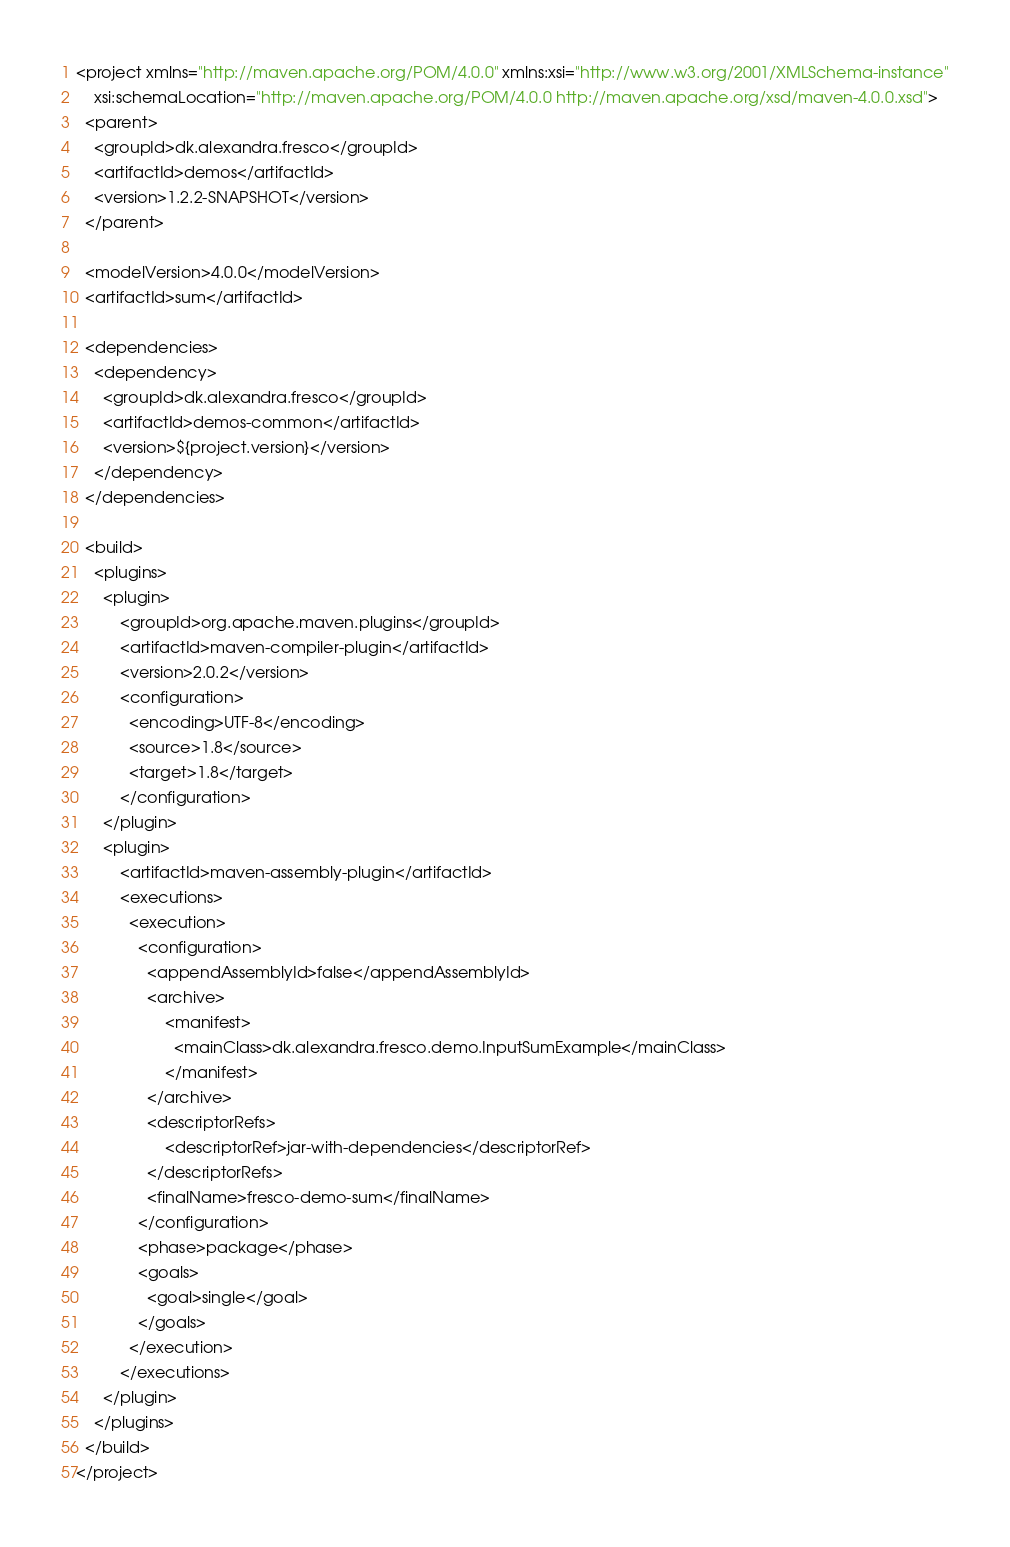<code> <loc_0><loc_0><loc_500><loc_500><_XML_><project xmlns="http://maven.apache.org/POM/4.0.0" xmlns:xsi="http://www.w3.org/2001/XMLSchema-instance"
    xsi:schemaLocation="http://maven.apache.org/POM/4.0.0 http://maven.apache.org/xsd/maven-4.0.0.xsd">
  <parent>
    <groupId>dk.alexandra.fresco</groupId>
    <artifactId>demos</artifactId>
    <version>1.2.2-SNAPSHOT</version>
  </parent>

  <modelVersion>4.0.0</modelVersion>
  <artifactId>sum</artifactId>

  <dependencies>
    <dependency>
      <groupId>dk.alexandra.fresco</groupId>
      <artifactId>demos-common</artifactId>
      <version>${project.version}</version>
    </dependency>
  </dependencies>
  
  <build>
    <plugins>
      <plugin>
	      <groupId>org.apache.maven.plugins</groupId>
	      <artifactId>maven-compiler-plugin</artifactId>
	      <version>2.0.2</version>
	      <configuration>
	        <encoding>UTF-8</encoding>
	        <source>1.8</source>
	        <target>1.8</target>
	      </configuration>
      </plugin>
      <plugin>
	      <artifactId>maven-assembly-plugin</artifactId>
	      <executions>
	        <execution>
	          <configuration>
	            <appendAssemblyId>false</appendAssemblyId>
	            <archive>
		            <manifest>
		              <mainClass>dk.alexandra.fresco.demo.InputSumExample</mainClass>
		            </manifest>
	            </archive>
	            <descriptorRefs>
		            <descriptorRef>jar-with-dependencies</descriptorRef>
	            </descriptorRefs>
	            <finalName>fresco-demo-sum</finalName>
	          </configuration>
	          <phase>package</phase>
	          <goals>
	            <goal>single</goal>
	          </goals>
	        </execution>
	      </executions>
      </plugin>
    </plugins>
  </build>
</project>
</code> 